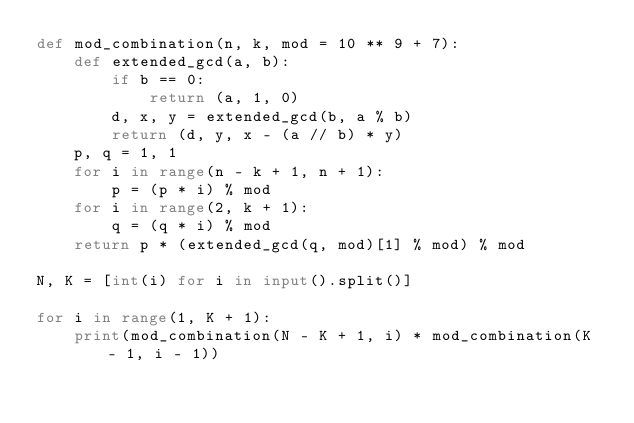<code> <loc_0><loc_0><loc_500><loc_500><_Python_>def mod_combination(n, k, mod = 10 ** 9 + 7):
    def extended_gcd(a, b):
        if b == 0:
            return (a, 1, 0)
        d, x, y = extended_gcd(b, a % b)
        return (d, y, x - (a // b) * y)
    p, q = 1, 1
    for i in range(n - k + 1, n + 1):
        p = (p * i) % mod
    for i in range(2, k + 1):
        q = (q * i) % mod
    return p * (extended_gcd(q, mod)[1] % mod) % mod

N, K = [int(i) for i in input().split()]

for i in range(1, K + 1):
    print(mod_combination(N - K + 1, i) * mod_combination(K - 1, i - 1))
</code> 